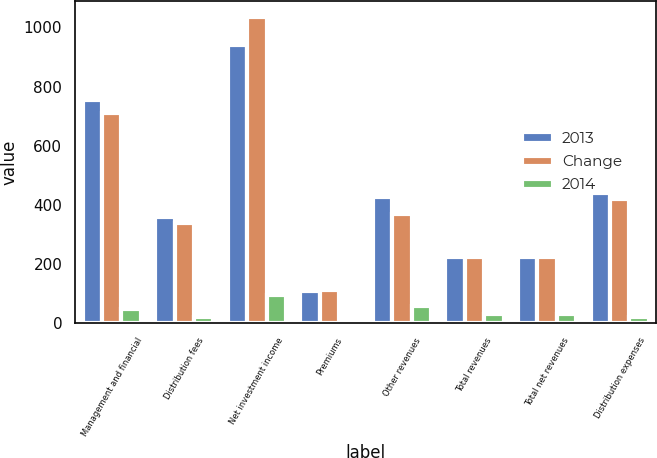Convert chart. <chart><loc_0><loc_0><loc_500><loc_500><stacked_bar_chart><ecel><fcel>Management and financial<fcel>Distribution fees<fcel>Net investment income<fcel>Premiums<fcel>Other revenues<fcel>Total revenues<fcel>Total net revenues<fcel>Distribution expenses<nl><fcel>2013<fcel>756<fcel>360<fcel>941<fcel>109<fcel>425<fcel>224.5<fcel>224.5<fcel>439<nl><fcel>Change<fcel>709<fcel>339<fcel>1036<fcel>110<fcel>367<fcel>224.5<fcel>224.5<fcel>420<nl><fcel>2014<fcel>47<fcel>21<fcel>95<fcel>1<fcel>58<fcel>30<fcel>30<fcel>19<nl></chart> 